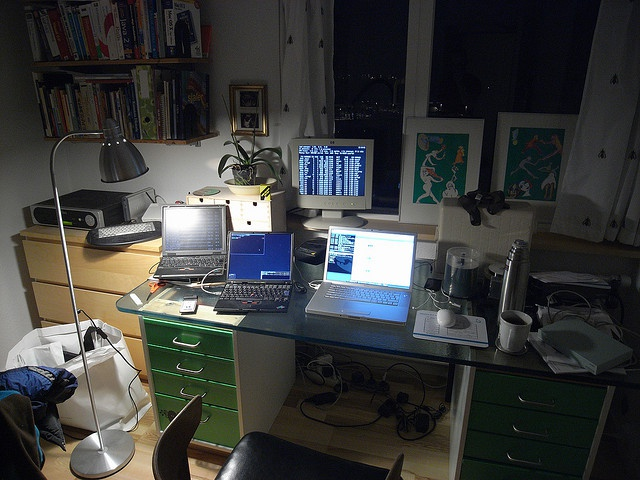Describe the objects in this image and their specific colors. I can see laptop in black, white, lightblue, and gray tones, chair in black, gray, darkgray, and lightgray tones, book in black tones, tv in black, gray, navy, and darkgray tones, and laptop in black, navy, darkblue, and gray tones in this image. 